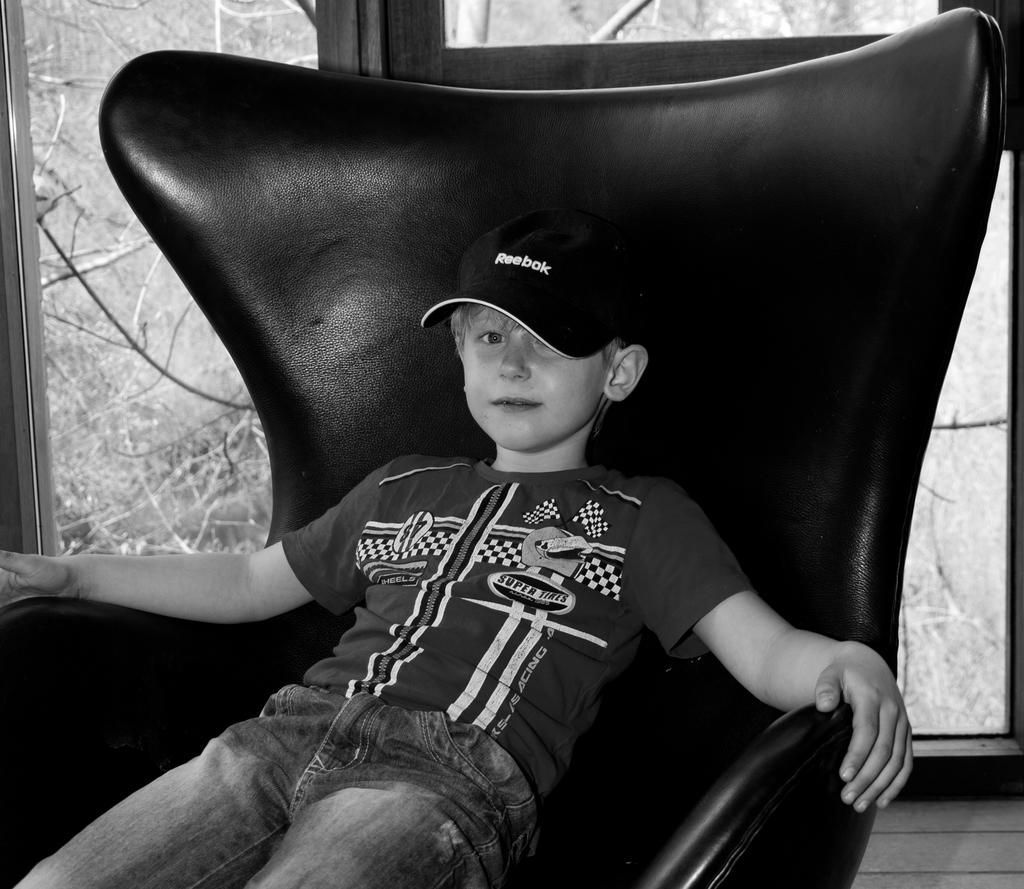Who is the main subject in the image? There is a boy in the image. What is the boy sitting on? The boy is sitting in a black chair. What is the boy wearing on his head? The boy is wearing a black cap. What type of pants is the boy wearing? The boy is wearing blue jeans. What can be seen in the background of the image? There is a door in the background of the image, and trees and plants are visible through the door. What type of crow can be seen flying through the mine in the image? There is no crow or mine present in the image. 